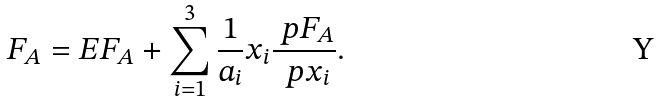Convert formula to latex. <formula><loc_0><loc_0><loc_500><loc_500>F _ { A } = E F _ { A } + \sum _ { i = 1 } ^ { 3 } \frac { 1 } { a _ { i } } x _ { i } \frac { \ p F _ { A } } { \ p x _ { i } } .</formula> 